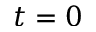Convert formula to latex. <formula><loc_0><loc_0><loc_500><loc_500>t = 0</formula> 